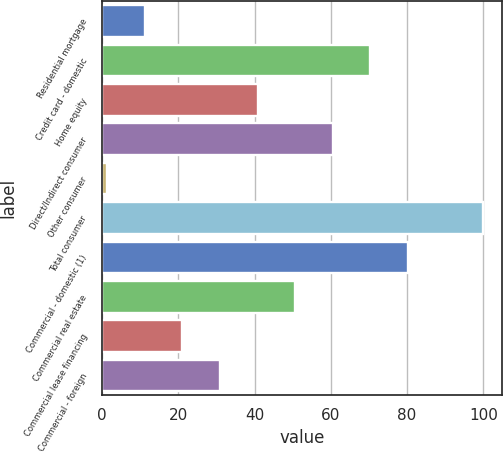Convert chart. <chart><loc_0><loc_0><loc_500><loc_500><bar_chart><fcel>Residential mortgage<fcel>Credit card - domestic<fcel>Home equity<fcel>Direct/Indirect consumer<fcel>Other consumer<fcel>Total consumer<fcel>Commercial - domestic (1)<fcel>Commercial real estate<fcel>Commercial lease financing<fcel>Commercial - foreign<nl><fcel>11.17<fcel>70.39<fcel>40.78<fcel>60.52<fcel>1.3<fcel>100<fcel>80.26<fcel>50.65<fcel>21.04<fcel>30.91<nl></chart> 